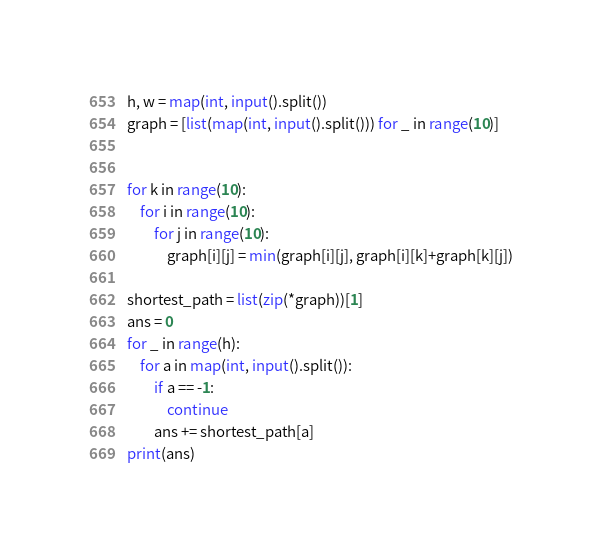Convert code to text. <code><loc_0><loc_0><loc_500><loc_500><_Python_>h, w = map(int, input().split())
graph = [list(map(int, input().split())) for _ in range(10)]


for k in range(10):
    for i in range(10):
        for j in range(10):
            graph[i][j] = min(graph[i][j], graph[i][k]+graph[k][j])

shortest_path = list(zip(*graph))[1]
ans = 0
for _ in range(h):
    for a in map(int, input().split()):
        if a == -1:
            continue
        ans += shortest_path[a]
print(ans)
</code> 